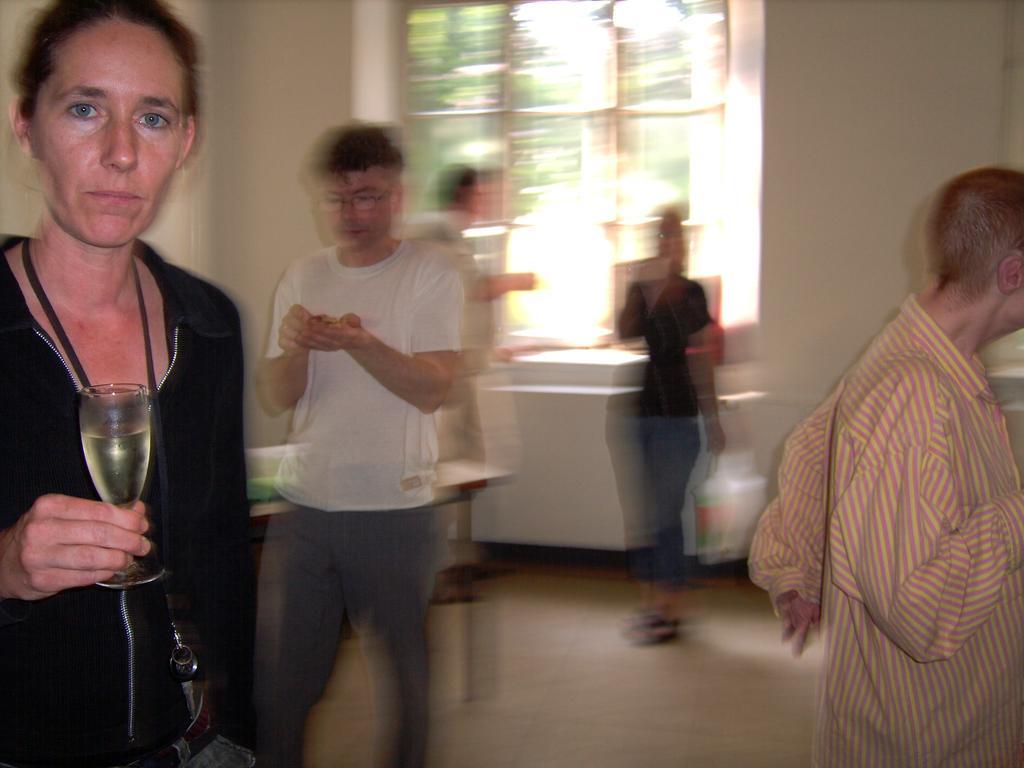Please provide a concise description of this image. There is a woman standing and holding a wine glass. At background there are four persons standing. This is a table with some object placed on it. I think this is a window. 